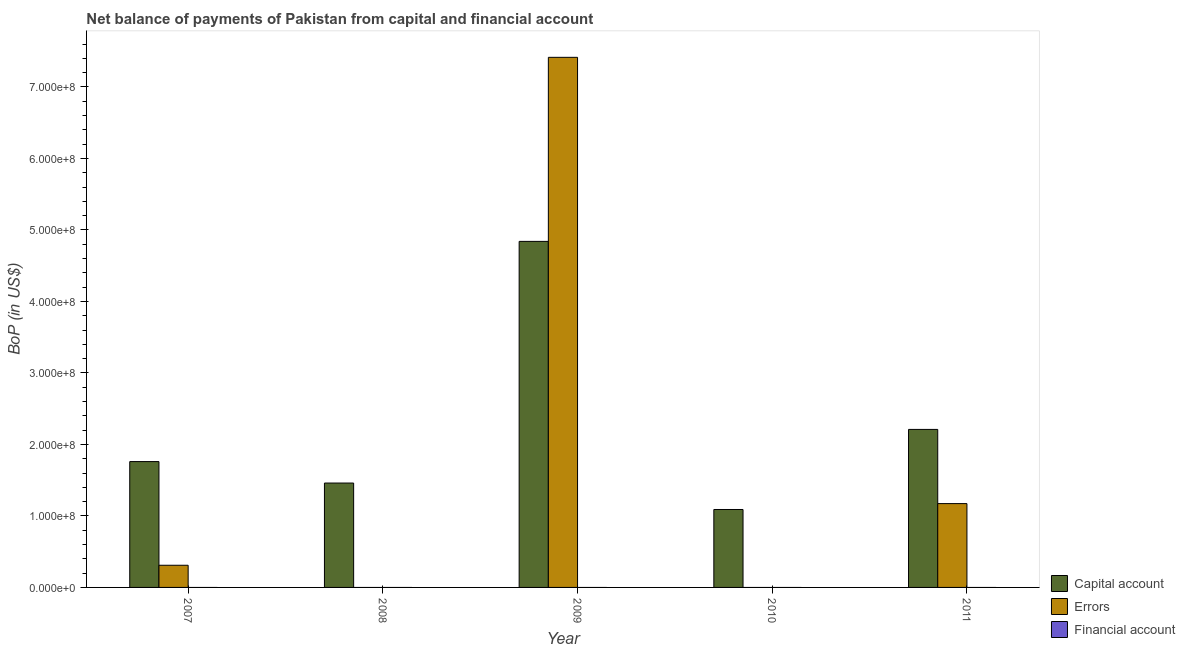How many different coloured bars are there?
Make the answer very short. 2. Are the number of bars on each tick of the X-axis equal?
Your answer should be very brief. No. How many bars are there on the 4th tick from the left?
Your answer should be compact. 1. In how many cases, is the number of bars for a given year not equal to the number of legend labels?
Keep it short and to the point. 5. What is the amount of net capital account in 2008?
Your answer should be compact. 1.46e+08. Across all years, what is the maximum amount of net capital account?
Your response must be concise. 4.84e+08. Across all years, what is the minimum amount of net capital account?
Keep it short and to the point. 1.09e+08. In which year was the amount of net capital account maximum?
Provide a succinct answer. 2009. What is the difference between the amount of net capital account in 2010 and that in 2011?
Provide a short and direct response. -1.12e+08. What is the difference between the amount of net capital account in 2007 and the amount of financial account in 2010?
Your answer should be compact. 6.70e+07. What is the average amount of net capital account per year?
Your answer should be very brief. 2.27e+08. In the year 2008, what is the difference between the amount of net capital account and amount of errors?
Provide a succinct answer. 0. What is the ratio of the amount of net capital account in 2008 to that in 2011?
Your answer should be very brief. 0.66. Is the amount of net capital account in 2007 less than that in 2009?
Your answer should be very brief. Yes. What is the difference between the highest and the second highest amount of net capital account?
Your answer should be very brief. 2.63e+08. What is the difference between the highest and the lowest amount of net capital account?
Give a very brief answer. 3.75e+08. In how many years, is the amount of financial account greater than the average amount of financial account taken over all years?
Offer a very short reply. 0. Is it the case that in every year, the sum of the amount of net capital account and amount of errors is greater than the amount of financial account?
Provide a succinct answer. Yes. Are the values on the major ticks of Y-axis written in scientific E-notation?
Provide a succinct answer. Yes. Does the graph contain any zero values?
Keep it short and to the point. Yes. Does the graph contain grids?
Your answer should be compact. No. Where does the legend appear in the graph?
Provide a short and direct response. Bottom right. How are the legend labels stacked?
Keep it short and to the point. Vertical. What is the title of the graph?
Offer a very short reply. Net balance of payments of Pakistan from capital and financial account. Does "Fuel" appear as one of the legend labels in the graph?
Your answer should be compact. No. What is the label or title of the X-axis?
Your response must be concise. Year. What is the label or title of the Y-axis?
Your answer should be very brief. BoP (in US$). What is the BoP (in US$) in Capital account in 2007?
Offer a very short reply. 1.76e+08. What is the BoP (in US$) of Errors in 2007?
Ensure brevity in your answer.  3.10e+07. What is the BoP (in US$) of Financial account in 2007?
Your response must be concise. 0. What is the BoP (in US$) in Capital account in 2008?
Your answer should be compact. 1.46e+08. What is the BoP (in US$) of Errors in 2008?
Offer a very short reply. 0. What is the BoP (in US$) in Financial account in 2008?
Make the answer very short. 0. What is the BoP (in US$) of Capital account in 2009?
Provide a short and direct response. 4.84e+08. What is the BoP (in US$) in Errors in 2009?
Provide a short and direct response. 7.41e+08. What is the BoP (in US$) of Capital account in 2010?
Your answer should be very brief. 1.09e+08. What is the BoP (in US$) of Capital account in 2011?
Your response must be concise. 2.21e+08. What is the BoP (in US$) in Errors in 2011?
Keep it short and to the point. 1.17e+08. Across all years, what is the maximum BoP (in US$) in Capital account?
Provide a short and direct response. 4.84e+08. Across all years, what is the maximum BoP (in US$) of Errors?
Give a very brief answer. 7.41e+08. Across all years, what is the minimum BoP (in US$) in Capital account?
Ensure brevity in your answer.  1.09e+08. Across all years, what is the minimum BoP (in US$) of Errors?
Your answer should be very brief. 0. What is the total BoP (in US$) in Capital account in the graph?
Your response must be concise. 1.14e+09. What is the total BoP (in US$) in Errors in the graph?
Offer a very short reply. 8.90e+08. What is the difference between the BoP (in US$) in Capital account in 2007 and that in 2008?
Your answer should be compact. 3.00e+07. What is the difference between the BoP (in US$) in Capital account in 2007 and that in 2009?
Ensure brevity in your answer.  -3.08e+08. What is the difference between the BoP (in US$) in Errors in 2007 and that in 2009?
Give a very brief answer. -7.10e+08. What is the difference between the BoP (in US$) of Capital account in 2007 and that in 2010?
Provide a short and direct response. 6.70e+07. What is the difference between the BoP (in US$) of Capital account in 2007 and that in 2011?
Provide a succinct answer. -4.50e+07. What is the difference between the BoP (in US$) in Errors in 2007 and that in 2011?
Provide a succinct answer. -8.62e+07. What is the difference between the BoP (in US$) of Capital account in 2008 and that in 2009?
Offer a very short reply. -3.38e+08. What is the difference between the BoP (in US$) in Capital account in 2008 and that in 2010?
Keep it short and to the point. 3.70e+07. What is the difference between the BoP (in US$) of Capital account in 2008 and that in 2011?
Your answer should be compact. -7.50e+07. What is the difference between the BoP (in US$) in Capital account in 2009 and that in 2010?
Keep it short and to the point. 3.75e+08. What is the difference between the BoP (in US$) of Capital account in 2009 and that in 2011?
Your response must be concise. 2.63e+08. What is the difference between the BoP (in US$) of Errors in 2009 and that in 2011?
Offer a terse response. 6.24e+08. What is the difference between the BoP (in US$) of Capital account in 2010 and that in 2011?
Make the answer very short. -1.12e+08. What is the difference between the BoP (in US$) of Capital account in 2007 and the BoP (in US$) of Errors in 2009?
Give a very brief answer. -5.65e+08. What is the difference between the BoP (in US$) of Capital account in 2007 and the BoP (in US$) of Errors in 2011?
Your answer should be very brief. 5.88e+07. What is the difference between the BoP (in US$) in Capital account in 2008 and the BoP (in US$) in Errors in 2009?
Your answer should be compact. -5.95e+08. What is the difference between the BoP (in US$) in Capital account in 2008 and the BoP (in US$) in Errors in 2011?
Keep it short and to the point. 2.88e+07. What is the difference between the BoP (in US$) in Capital account in 2009 and the BoP (in US$) in Errors in 2011?
Provide a succinct answer. 3.67e+08. What is the difference between the BoP (in US$) in Capital account in 2010 and the BoP (in US$) in Errors in 2011?
Your answer should be very brief. -8.25e+06. What is the average BoP (in US$) in Capital account per year?
Give a very brief answer. 2.27e+08. What is the average BoP (in US$) of Errors per year?
Keep it short and to the point. 1.78e+08. In the year 2007, what is the difference between the BoP (in US$) in Capital account and BoP (in US$) in Errors?
Ensure brevity in your answer.  1.45e+08. In the year 2009, what is the difference between the BoP (in US$) of Capital account and BoP (in US$) of Errors?
Keep it short and to the point. -2.57e+08. In the year 2011, what is the difference between the BoP (in US$) of Capital account and BoP (in US$) of Errors?
Your response must be concise. 1.04e+08. What is the ratio of the BoP (in US$) in Capital account in 2007 to that in 2008?
Provide a short and direct response. 1.21. What is the ratio of the BoP (in US$) in Capital account in 2007 to that in 2009?
Your answer should be compact. 0.36. What is the ratio of the BoP (in US$) of Errors in 2007 to that in 2009?
Offer a very short reply. 0.04. What is the ratio of the BoP (in US$) of Capital account in 2007 to that in 2010?
Offer a very short reply. 1.61. What is the ratio of the BoP (in US$) in Capital account in 2007 to that in 2011?
Provide a succinct answer. 0.8. What is the ratio of the BoP (in US$) in Errors in 2007 to that in 2011?
Provide a short and direct response. 0.26. What is the ratio of the BoP (in US$) in Capital account in 2008 to that in 2009?
Your answer should be very brief. 0.3. What is the ratio of the BoP (in US$) of Capital account in 2008 to that in 2010?
Your answer should be compact. 1.34. What is the ratio of the BoP (in US$) of Capital account in 2008 to that in 2011?
Your response must be concise. 0.66. What is the ratio of the BoP (in US$) in Capital account in 2009 to that in 2010?
Your answer should be compact. 4.44. What is the ratio of the BoP (in US$) of Capital account in 2009 to that in 2011?
Give a very brief answer. 2.19. What is the ratio of the BoP (in US$) of Errors in 2009 to that in 2011?
Keep it short and to the point. 6.32. What is the ratio of the BoP (in US$) in Capital account in 2010 to that in 2011?
Your response must be concise. 0.49. What is the difference between the highest and the second highest BoP (in US$) in Capital account?
Your answer should be very brief. 2.63e+08. What is the difference between the highest and the second highest BoP (in US$) of Errors?
Provide a succinct answer. 6.24e+08. What is the difference between the highest and the lowest BoP (in US$) in Capital account?
Your response must be concise. 3.75e+08. What is the difference between the highest and the lowest BoP (in US$) of Errors?
Provide a succinct answer. 7.41e+08. 